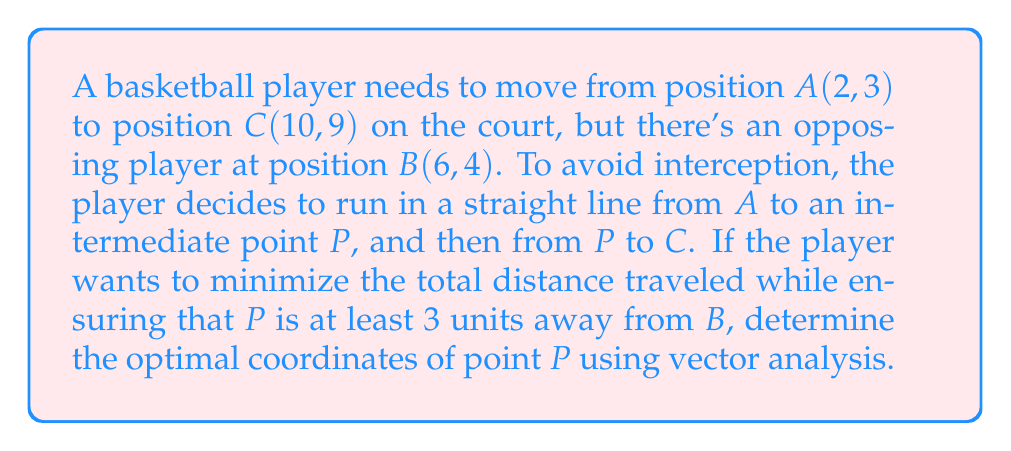What is the answer to this math problem? Let's approach this step-by-step using vector analysis:

1) First, let's define our vectors:
   $\vec{AB} = (4, 1)$
   $\vec{AC} = (8, 6)$

2) We can represent point P as:
   $P = A + t\vec{AC} = (2+8t, 3+6t)$, where $0 \leq t \leq 1$

3) The distance from P to B should be at least 3 units. We can express this as:
   $|\vec{BP}|^2 \geq 3^2$

4) Expand this inequality:
   $((2+8t-6)^2 + (3+6t-4)^2 \geq 9$
   $(8t-4)^2 + (6t-1)^2 \geq 9$
   $64t^2-64t+16 + 36t^2-12t+1 \geq 9$
   $100t^2-76t+8 \geq 0$

5) Solve this quadratic inequality:
   $t \leq 0.38$ or $t \geq 0.78$

6) The total distance traveled is:
   $d = |\vec{AP}| + |\vec{PC}| = \sqrt{64t^2+36t^2} + \sqrt{64(1-t)^2+36(1-t)^2}$
      $= 10t + 10(1-t) = 10$

7) Since the total distance is constant regardless of t, we should choose t to be as close to 0.5 as possible while satisfying the inequality from step 5.

8) Therefore, the optimal t is 0.38.

9) The coordinates of P are:
   $P = (2+8(0.38), 3+6(0.38)) = (5.04, 5.28)$

[asy]
unitsize(20);
dot((2,3));
dot((10,9));
dot((6,4));
dot((5.04,5.28));
draw((2,3)--(5.04,5.28)--(10,9), red);
draw(circle((6,4),3), dashed);
label("A", (2,3), SW);
label("C", (10,9), NE);
label("B", (6,4), SE);
label("P", (5.04,5.28), NW);
[/asy]
Answer: The optimal coordinates of point P are approximately (5.04, 5.28). 